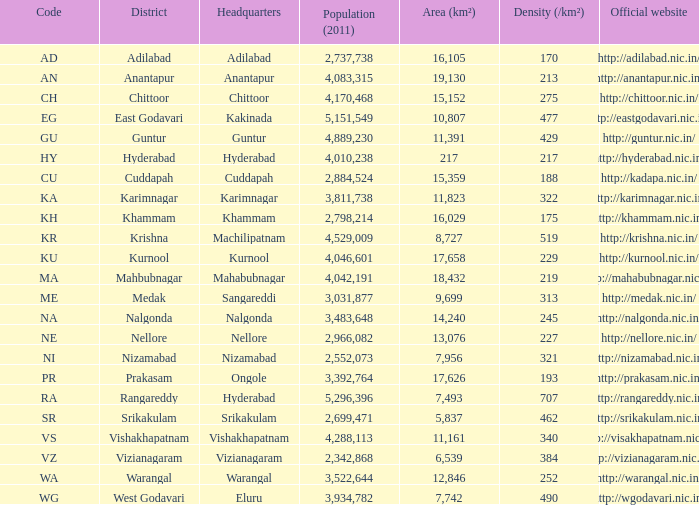What is the combined area value for districts possessing density greater than 462 and websites with http://krishna.nic.in/? 8727.0. 